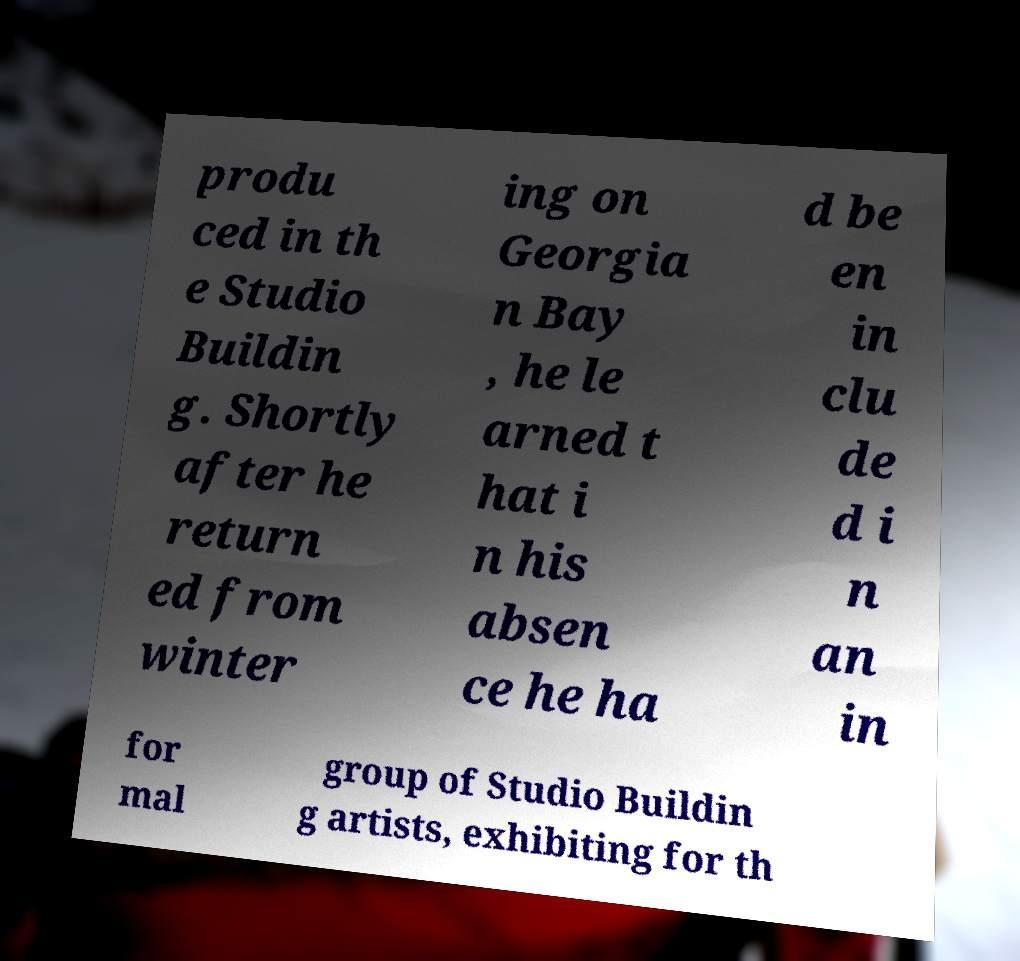Please read and relay the text visible in this image. What does it say? produ ced in th e Studio Buildin g. Shortly after he return ed from winter ing on Georgia n Bay , he le arned t hat i n his absen ce he ha d be en in clu de d i n an in for mal group of Studio Buildin g artists, exhibiting for th 